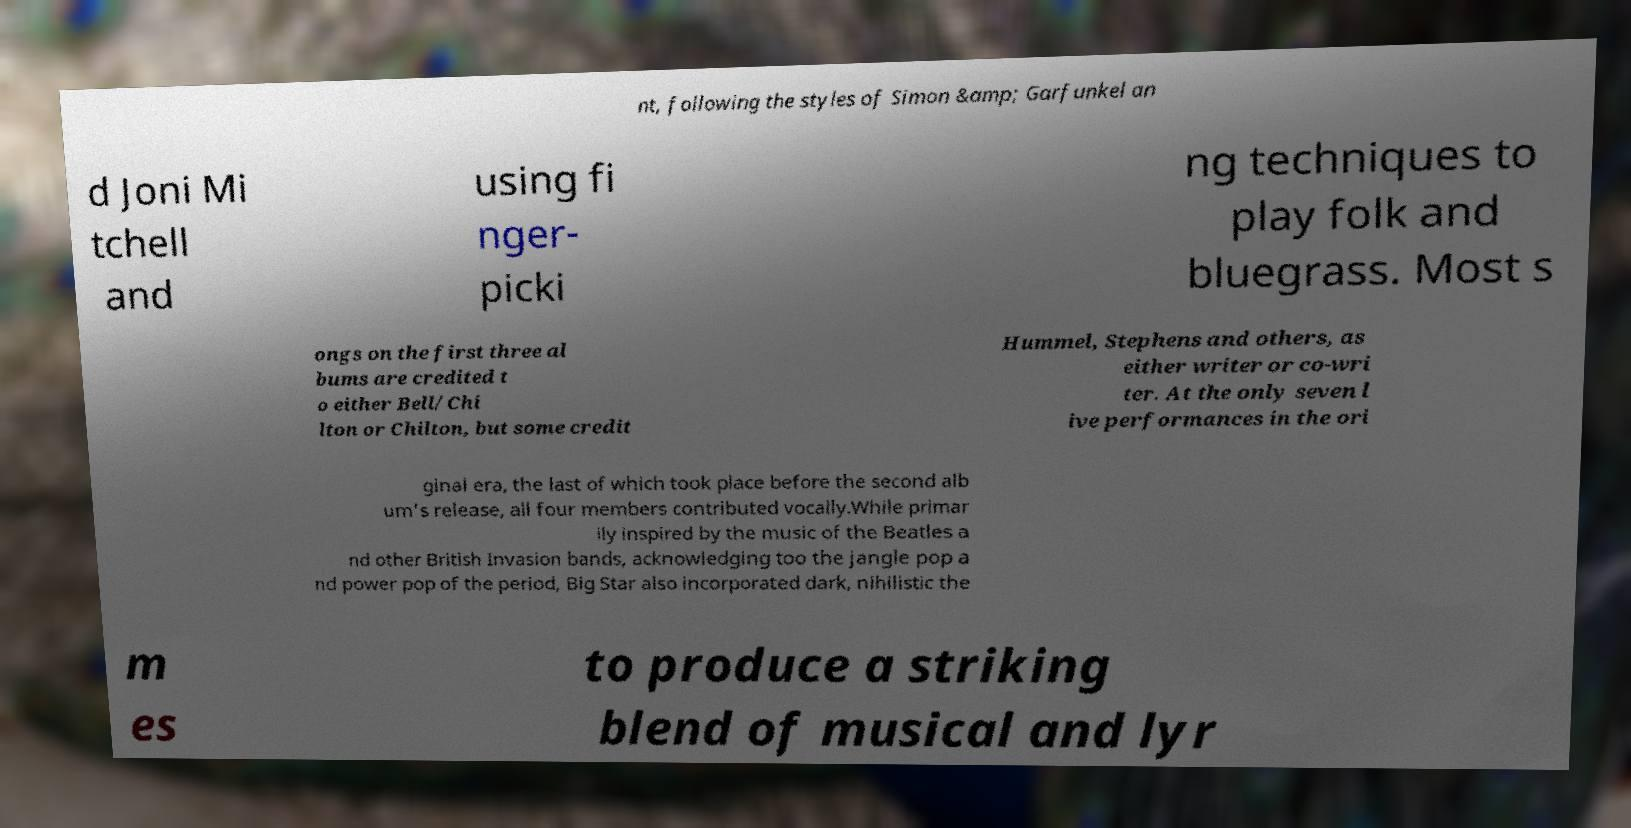I need the written content from this picture converted into text. Can you do that? nt, following the styles of Simon &amp; Garfunkel an d Joni Mi tchell and using fi nger- picki ng techniques to play folk and bluegrass. Most s ongs on the first three al bums are credited t o either Bell/Chi lton or Chilton, but some credit Hummel, Stephens and others, as either writer or co-wri ter. At the only seven l ive performances in the ori ginal era, the last of which took place before the second alb um's release, all four members contributed vocally.While primar ily inspired by the music of the Beatles a nd other British Invasion bands, acknowledging too the jangle pop a nd power pop of the period, Big Star also incorporated dark, nihilistic the m es to produce a striking blend of musical and lyr 